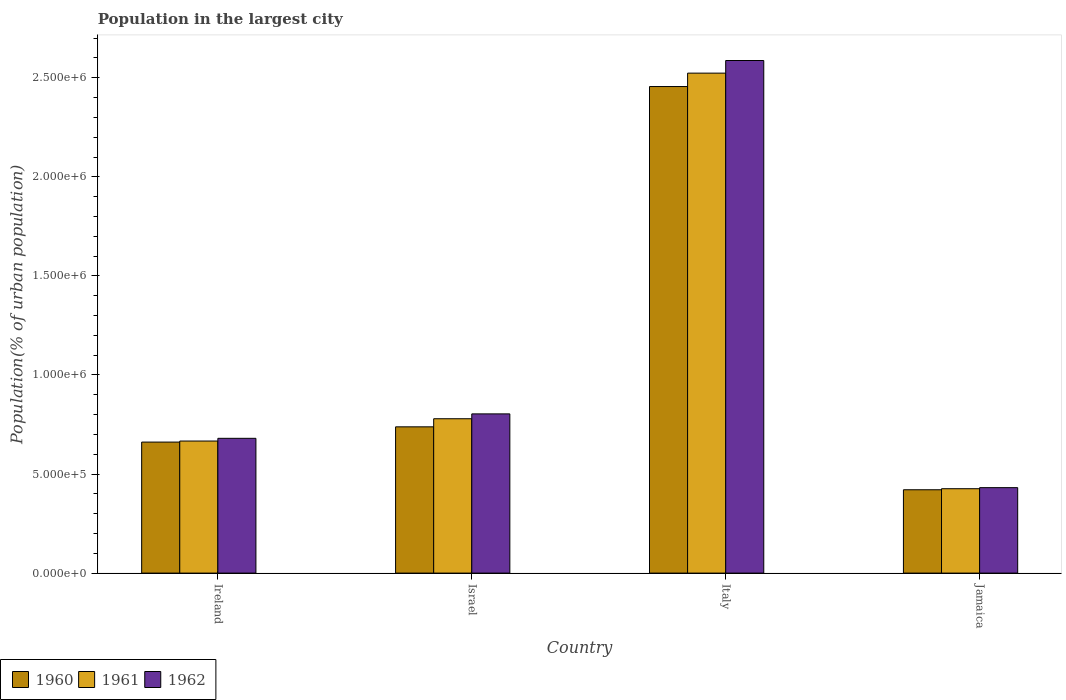How many different coloured bars are there?
Give a very brief answer. 3. Are the number of bars per tick equal to the number of legend labels?
Offer a very short reply. Yes. Are the number of bars on each tick of the X-axis equal?
Keep it short and to the point. Yes. How many bars are there on the 4th tick from the left?
Offer a very short reply. 3. In how many cases, is the number of bars for a given country not equal to the number of legend labels?
Ensure brevity in your answer.  0. What is the population in the largest city in 1962 in Jamaica?
Offer a terse response. 4.31e+05. Across all countries, what is the maximum population in the largest city in 1962?
Offer a terse response. 2.59e+06. Across all countries, what is the minimum population in the largest city in 1962?
Your answer should be very brief. 4.31e+05. In which country was the population in the largest city in 1962 maximum?
Your answer should be compact. Italy. In which country was the population in the largest city in 1962 minimum?
Provide a succinct answer. Jamaica. What is the total population in the largest city in 1961 in the graph?
Provide a succinct answer. 4.39e+06. What is the difference between the population in the largest city in 1960 in Italy and that in Jamaica?
Offer a very short reply. 2.03e+06. What is the difference between the population in the largest city in 1962 in Jamaica and the population in the largest city in 1961 in Ireland?
Make the answer very short. -2.35e+05. What is the average population in the largest city in 1961 per country?
Make the answer very short. 1.10e+06. What is the difference between the population in the largest city of/in 1961 and population in the largest city of/in 1962 in Italy?
Provide a short and direct response. -6.37e+04. In how many countries, is the population in the largest city in 1962 greater than 400000 %?
Provide a short and direct response. 4. What is the ratio of the population in the largest city in 1962 in Ireland to that in Israel?
Give a very brief answer. 0.85. Is the population in the largest city in 1960 in Ireland less than that in Israel?
Your answer should be compact. Yes. Is the difference between the population in the largest city in 1961 in Ireland and Jamaica greater than the difference between the population in the largest city in 1962 in Ireland and Jamaica?
Provide a succinct answer. No. What is the difference between the highest and the second highest population in the largest city in 1962?
Provide a short and direct response. 1.91e+06. What is the difference between the highest and the lowest population in the largest city in 1962?
Ensure brevity in your answer.  2.16e+06. What does the 1st bar from the left in Italy represents?
Your answer should be very brief. 1960. What does the 1st bar from the right in Jamaica represents?
Your answer should be compact. 1962. How many bars are there?
Your response must be concise. 12. Are all the bars in the graph horizontal?
Offer a terse response. No. How many countries are there in the graph?
Your answer should be compact. 4. What is the difference between two consecutive major ticks on the Y-axis?
Keep it short and to the point. 5.00e+05. Are the values on the major ticks of Y-axis written in scientific E-notation?
Provide a succinct answer. Yes. Does the graph contain any zero values?
Offer a terse response. No. Does the graph contain grids?
Provide a short and direct response. No. Where does the legend appear in the graph?
Make the answer very short. Bottom left. What is the title of the graph?
Offer a terse response. Population in the largest city. Does "1996" appear as one of the legend labels in the graph?
Provide a short and direct response. No. What is the label or title of the Y-axis?
Your answer should be compact. Population(% of urban population). What is the Population(% of urban population) in 1960 in Ireland?
Keep it short and to the point. 6.61e+05. What is the Population(% of urban population) of 1961 in Ireland?
Your answer should be very brief. 6.66e+05. What is the Population(% of urban population) in 1962 in Ireland?
Keep it short and to the point. 6.80e+05. What is the Population(% of urban population) of 1960 in Israel?
Offer a very short reply. 7.38e+05. What is the Population(% of urban population) of 1961 in Israel?
Offer a terse response. 7.79e+05. What is the Population(% of urban population) in 1962 in Israel?
Keep it short and to the point. 8.04e+05. What is the Population(% of urban population) of 1960 in Italy?
Give a very brief answer. 2.46e+06. What is the Population(% of urban population) of 1961 in Italy?
Provide a succinct answer. 2.52e+06. What is the Population(% of urban population) of 1962 in Italy?
Offer a very short reply. 2.59e+06. What is the Population(% of urban population) of 1960 in Jamaica?
Make the answer very short. 4.21e+05. What is the Population(% of urban population) in 1961 in Jamaica?
Keep it short and to the point. 4.26e+05. What is the Population(% of urban population) in 1962 in Jamaica?
Ensure brevity in your answer.  4.31e+05. Across all countries, what is the maximum Population(% of urban population) in 1960?
Your answer should be compact. 2.46e+06. Across all countries, what is the maximum Population(% of urban population) of 1961?
Keep it short and to the point. 2.52e+06. Across all countries, what is the maximum Population(% of urban population) in 1962?
Make the answer very short. 2.59e+06. Across all countries, what is the minimum Population(% of urban population) of 1960?
Offer a very short reply. 4.21e+05. Across all countries, what is the minimum Population(% of urban population) of 1961?
Keep it short and to the point. 4.26e+05. Across all countries, what is the minimum Population(% of urban population) of 1962?
Your answer should be very brief. 4.31e+05. What is the total Population(% of urban population) of 1960 in the graph?
Make the answer very short. 4.28e+06. What is the total Population(% of urban population) in 1961 in the graph?
Your answer should be compact. 4.39e+06. What is the total Population(% of urban population) in 1962 in the graph?
Keep it short and to the point. 4.50e+06. What is the difference between the Population(% of urban population) in 1960 in Ireland and that in Israel?
Offer a very short reply. -7.70e+04. What is the difference between the Population(% of urban population) in 1961 in Ireland and that in Israel?
Give a very brief answer. -1.13e+05. What is the difference between the Population(% of urban population) in 1962 in Ireland and that in Israel?
Offer a terse response. -1.23e+05. What is the difference between the Population(% of urban population) in 1960 in Ireland and that in Italy?
Give a very brief answer. -1.79e+06. What is the difference between the Population(% of urban population) of 1961 in Ireland and that in Italy?
Make the answer very short. -1.86e+06. What is the difference between the Population(% of urban population) of 1962 in Ireland and that in Italy?
Offer a very short reply. -1.91e+06. What is the difference between the Population(% of urban population) of 1960 in Ireland and that in Jamaica?
Provide a succinct answer. 2.41e+05. What is the difference between the Population(% of urban population) of 1961 in Ireland and that in Jamaica?
Give a very brief answer. 2.41e+05. What is the difference between the Population(% of urban population) of 1962 in Ireland and that in Jamaica?
Give a very brief answer. 2.49e+05. What is the difference between the Population(% of urban population) in 1960 in Israel and that in Italy?
Your answer should be compact. -1.72e+06. What is the difference between the Population(% of urban population) of 1961 in Israel and that in Italy?
Offer a very short reply. -1.74e+06. What is the difference between the Population(% of urban population) of 1962 in Israel and that in Italy?
Offer a very short reply. -1.78e+06. What is the difference between the Population(% of urban population) of 1960 in Israel and that in Jamaica?
Offer a terse response. 3.18e+05. What is the difference between the Population(% of urban population) of 1961 in Israel and that in Jamaica?
Provide a succinct answer. 3.53e+05. What is the difference between the Population(% of urban population) of 1962 in Israel and that in Jamaica?
Provide a succinct answer. 3.72e+05. What is the difference between the Population(% of urban population) in 1960 in Italy and that in Jamaica?
Make the answer very short. 2.03e+06. What is the difference between the Population(% of urban population) in 1961 in Italy and that in Jamaica?
Make the answer very short. 2.10e+06. What is the difference between the Population(% of urban population) of 1962 in Italy and that in Jamaica?
Make the answer very short. 2.16e+06. What is the difference between the Population(% of urban population) of 1960 in Ireland and the Population(% of urban population) of 1961 in Israel?
Keep it short and to the point. -1.18e+05. What is the difference between the Population(% of urban population) of 1960 in Ireland and the Population(% of urban population) of 1962 in Israel?
Provide a short and direct response. -1.42e+05. What is the difference between the Population(% of urban population) in 1961 in Ireland and the Population(% of urban population) in 1962 in Israel?
Offer a very short reply. -1.37e+05. What is the difference between the Population(% of urban population) in 1960 in Ireland and the Population(% of urban population) in 1961 in Italy?
Give a very brief answer. -1.86e+06. What is the difference between the Population(% of urban population) in 1960 in Ireland and the Population(% of urban population) in 1962 in Italy?
Make the answer very short. -1.93e+06. What is the difference between the Population(% of urban population) of 1961 in Ireland and the Population(% of urban population) of 1962 in Italy?
Give a very brief answer. -1.92e+06. What is the difference between the Population(% of urban population) of 1960 in Ireland and the Population(% of urban population) of 1961 in Jamaica?
Keep it short and to the point. 2.35e+05. What is the difference between the Population(% of urban population) in 1960 in Ireland and the Population(% of urban population) in 1962 in Jamaica?
Give a very brief answer. 2.30e+05. What is the difference between the Population(% of urban population) of 1961 in Ireland and the Population(% of urban population) of 1962 in Jamaica?
Keep it short and to the point. 2.35e+05. What is the difference between the Population(% of urban population) in 1960 in Israel and the Population(% of urban population) in 1961 in Italy?
Offer a very short reply. -1.79e+06. What is the difference between the Population(% of urban population) in 1960 in Israel and the Population(% of urban population) in 1962 in Italy?
Give a very brief answer. -1.85e+06. What is the difference between the Population(% of urban population) in 1961 in Israel and the Population(% of urban population) in 1962 in Italy?
Give a very brief answer. -1.81e+06. What is the difference between the Population(% of urban population) in 1960 in Israel and the Population(% of urban population) in 1961 in Jamaica?
Offer a terse response. 3.12e+05. What is the difference between the Population(% of urban population) in 1960 in Israel and the Population(% of urban population) in 1962 in Jamaica?
Provide a short and direct response. 3.07e+05. What is the difference between the Population(% of urban population) of 1961 in Israel and the Population(% of urban population) of 1962 in Jamaica?
Provide a succinct answer. 3.48e+05. What is the difference between the Population(% of urban population) in 1960 in Italy and the Population(% of urban population) in 1961 in Jamaica?
Your response must be concise. 2.03e+06. What is the difference between the Population(% of urban population) in 1960 in Italy and the Population(% of urban population) in 1962 in Jamaica?
Keep it short and to the point. 2.02e+06. What is the difference between the Population(% of urban population) of 1961 in Italy and the Population(% of urban population) of 1962 in Jamaica?
Offer a very short reply. 2.09e+06. What is the average Population(% of urban population) in 1960 per country?
Ensure brevity in your answer.  1.07e+06. What is the average Population(% of urban population) of 1961 per country?
Your answer should be very brief. 1.10e+06. What is the average Population(% of urban population) in 1962 per country?
Ensure brevity in your answer.  1.13e+06. What is the difference between the Population(% of urban population) of 1960 and Population(% of urban population) of 1961 in Ireland?
Offer a terse response. -5272. What is the difference between the Population(% of urban population) in 1960 and Population(% of urban population) in 1962 in Ireland?
Offer a terse response. -1.90e+04. What is the difference between the Population(% of urban population) in 1961 and Population(% of urban population) in 1962 in Ireland?
Your response must be concise. -1.37e+04. What is the difference between the Population(% of urban population) in 1960 and Population(% of urban population) in 1961 in Israel?
Your answer should be compact. -4.09e+04. What is the difference between the Population(% of urban population) in 1960 and Population(% of urban population) in 1962 in Israel?
Make the answer very short. -6.54e+04. What is the difference between the Population(% of urban population) in 1961 and Population(% of urban population) in 1962 in Israel?
Provide a short and direct response. -2.45e+04. What is the difference between the Population(% of urban population) in 1960 and Population(% of urban population) in 1961 in Italy?
Keep it short and to the point. -6.77e+04. What is the difference between the Population(% of urban population) in 1960 and Population(% of urban population) in 1962 in Italy?
Your answer should be very brief. -1.31e+05. What is the difference between the Population(% of urban population) of 1961 and Population(% of urban population) of 1962 in Italy?
Make the answer very short. -6.37e+04. What is the difference between the Population(% of urban population) in 1960 and Population(% of urban population) in 1961 in Jamaica?
Offer a very short reply. -5262. What is the difference between the Population(% of urban population) of 1960 and Population(% of urban population) of 1962 in Jamaica?
Keep it short and to the point. -1.06e+04. What is the difference between the Population(% of urban population) of 1961 and Population(% of urban population) of 1962 in Jamaica?
Offer a terse response. -5334. What is the ratio of the Population(% of urban population) of 1960 in Ireland to that in Israel?
Your response must be concise. 0.9. What is the ratio of the Population(% of urban population) of 1961 in Ireland to that in Israel?
Ensure brevity in your answer.  0.86. What is the ratio of the Population(% of urban population) of 1962 in Ireland to that in Israel?
Give a very brief answer. 0.85. What is the ratio of the Population(% of urban population) of 1960 in Ireland to that in Italy?
Provide a succinct answer. 0.27. What is the ratio of the Population(% of urban population) in 1961 in Ireland to that in Italy?
Your answer should be very brief. 0.26. What is the ratio of the Population(% of urban population) in 1962 in Ireland to that in Italy?
Give a very brief answer. 0.26. What is the ratio of the Population(% of urban population) of 1960 in Ireland to that in Jamaica?
Ensure brevity in your answer.  1.57. What is the ratio of the Population(% of urban population) of 1961 in Ireland to that in Jamaica?
Provide a short and direct response. 1.56. What is the ratio of the Population(% of urban population) in 1962 in Ireland to that in Jamaica?
Ensure brevity in your answer.  1.58. What is the ratio of the Population(% of urban population) in 1960 in Israel to that in Italy?
Provide a short and direct response. 0.3. What is the ratio of the Population(% of urban population) of 1961 in Israel to that in Italy?
Your answer should be compact. 0.31. What is the ratio of the Population(% of urban population) of 1962 in Israel to that in Italy?
Ensure brevity in your answer.  0.31. What is the ratio of the Population(% of urban population) in 1960 in Israel to that in Jamaica?
Your response must be concise. 1.75. What is the ratio of the Population(% of urban population) of 1961 in Israel to that in Jamaica?
Your response must be concise. 1.83. What is the ratio of the Population(% of urban population) in 1962 in Israel to that in Jamaica?
Your answer should be very brief. 1.86. What is the ratio of the Population(% of urban population) of 1960 in Italy to that in Jamaica?
Offer a terse response. 5.84. What is the ratio of the Population(% of urban population) of 1961 in Italy to that in Jamaica?
Ensure brevity in your answer.  5.92. What is the ratio of the Population(% of urban population) of 1962 in Italy to that in Jamaica?
Keep it short and to the point. 6. What is the difference between the highest and the second highest Population(% of urban population) in 1960?
Offer a terse response. 1.72e+06. What is the difference between the highest and the second highest Population(% of urban population) in 1961?
Offer a terse response. 1.74e+06. What is the difference between the highest and the second highest Population(% of urban population) of 1962?
Provide a succinct answer. 1.78e+06. What is the difference between the highest and the lowest Population(% of urban population) of 1960?
Provide a succinct answer. 2.03e+06. What is the difference between the highest and the lowest Population(% of urban population) of 1961?
Give a very brief answer. 2.10e+06. What is the difference between the highest and the lowest Population(% of urban population) in 1962?
Give a very brief answer. 2.16e+06. 